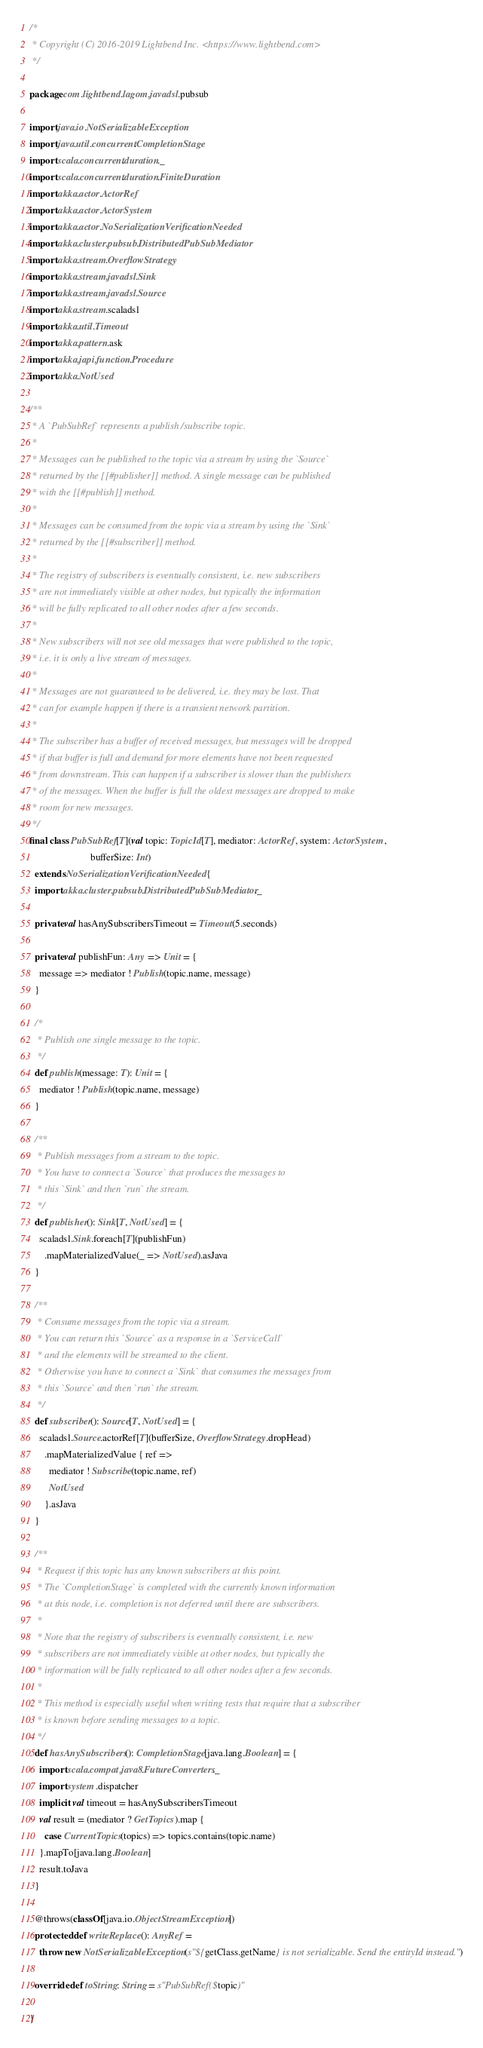<code> <loc_0><loc_0><loc_500><loc_500><_Scala_>/*
 * Copyright (C) 2016-2019 Lightbend Inc. <https://www.lightbend.com>
 */

package com.lightbend.lagom.javadsl.pubsub

import java.io.NotSerializableException
import java.util.concurrent.CompletionStage
import scala.concurrent.duration._
import scala.concurrent.duration.FiniteDuration
import akka.actor.ActorRef
import akka.actor.ActorSystem
import akka.actor.NoSerializationVerificationNeeded
import akka.cluster.pubsub.DistributedPubSubMediator
import akka.stream.OverflowStrategy
import akka.stream.javadsl.Sink
import akka.stream.javadsl.Source
import akka.stream.scaladsl
import akka.util.Timeout
import akka.pattern.ask
import akka.japi.function.Procedure
import akka.NotUsed

/**
 * A `PubSubRef` represents a publish/subscribe topic.
 *
 * Messages can be published to the topic via a stream by using the `Source`
 * returned by the [[#publisher]] method. A single message can be published
 * with the [[#publish]] method.
 *
 * Messages can be consumed from the topic via a stream by using the `Sink`
 * returned by the [[#subscriber]] method.
 *
 * The registry of subscribers is eventually consistent, i.e. new subscribers
 * are not immediately visible at other nodes, but typically the information
 * will be fully replicated to all other nodes after a few seconds.
 *
 * New subscribers will not see old messages that were published to the topic,
 * i.e. it is only a live stream of messages.
 *
 * Messages are not guaranteed to be delivered, i.e. they may be lost. That
 * can for example happen if there is a transient network partition.
 *
 * The subscriber has a buffer of received messages, but messages will be dropped
 * if that buffer is full and demand for more elements have not been requested
 * from downstream. This can happen if a subscriber is slower than the publishers
 * of the messages. When the buffer is full the oldest messages are dropped to make
 * room for new messages.
 */
final class PubSubRef[T](val topic: TopicId[T], mediator: ActorRef, system: ActorSystem,
                         bufferSize: Int)
  extends NoSerializationVerificationNeeded {
  import akka.cluster.pubsub.DistributedPubSubMediator._

  private val hasAnySubscribersTimeout = Timeout(5.seconds)

  private val publishFun: Any => Unit = {
    message => mediator ! Publish(topic.name, message)
  }

  /*
   * Publish one single message to the topic.
   */
  def publish(message: T): Unit = {
    mediator ! Publish(topic.name, message)
  }

  /**
   * Publish messages from a stream to the topic.
   * You have to connect a `Source` that produces the messages to
   * this `Sink` and then `run` the stream.
   */
  def publisher(): Sink[T, NotUsed] = {
    scaladsl.Sink.foreach[T](publishFun)
      .mapMaterializedValue(_ => NotUsed).asJava
  }

  /**
   * Consume messages from the topic via a stream.
   * You can return this `Source` as a response in a `ServiceCall`
   * and the elements will be streamed to the client.
   * Otherwise you have to connect a `Sink` that consumes the messages from
   * this `Source` and then `run` the stream.
   */
  def subscriber(): Source[T, NotUsed] = {
    scaladsl.Source.actorRef[T](bufferSize, OverflowStrategy.dropHead)
      .mapMaterializedValue { ref =>
        mediator ! Subscribe(topic.name, ref)
        NotUsed
      }.asJava
  }

  /**
   * Request if this topic has any known subscribers at this point.
   * The `CompletionStage` is completed with the currently known information
   * at this node, i.e. completion is not deferred until there are subscribers.
   *
   * Note that the registry of subscribers is eventually consistent, i.e. new
   * subscribers are not immediately visible at other nodes, but typically the
   * information will be fully replicated to all other nodes after a few seconds.
   *
   * This method is especially useful when writing tests that require that a subscriber
   * is known before sending messages to a topic.
   */
  def hasAnySubscribers(): CompletionStage[java.lang.Boolean] = {
    import scala.compat.java8.FutureConverters._
    import system.dispatcher
    implicit val timeout = hasAnySubscribersTimeout
    val result = (mediator ? GetTopics).map {
      case CurrentTopics(topics) => topics.contains(topic.name)
    }.mapTo[java.lang.Boolean]
    result.toJava
  }

  @throws(classOf[java.io.ObjectStreamException])
  protected def writeReplace(): AnyRef =
    throw new NotSerializableException(s"${getClass.getName} is not serializable. Send the entityId instead.")

  override def toString: String = s"PubSubRef($topic)"

}
</code> 